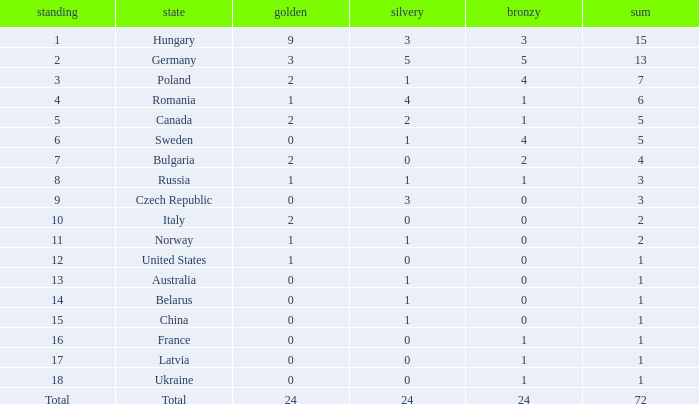Parse the table in full. {'header': ['standing', 'state', 'golden', 'silvery', 'bronzy', 'sum'], 'rows': [['1', 'Hungary', '9', '3', '3', '15'], ['2', 'Germany', '3', '5', '5', '13'], ['3', 'Poland', '2', '1', '4', '7'], ['4', 'Romania', '1', '4', '1', '6'], ['5', 'Canada', '2', '2', '1', '5'], ['6', 'Sweden', '0', '1', '4', '5'], ['7', 'Bulgaria', '2', '0', '2', '4'], ['8', 'Russia', '1', '1', '1', '3'], ['9', 'Czech Republic', '0', '3', '0', '3'], ['10', 'Italy', '2', '0', '0', '2'], ['11', 'Norway', '1', '1', '0', '2'], ['12', 'United States', '1', '0', '0', '1'], ['13', 'Australia', '0', '1', '0', '1'], ['14', 'Belarus', '0', '1', '0', '1'], ['15', 'China', '0', '1', '0', '1'], ['16', 'France', '0', '0', '1', '1'], ['17', 'Latvia', '0', '0', '1', '1'], ['18', 'Ukraine', '0', '0', '1', '1'], ['Total', 'Total', '24', '24', '24', '72']]} What nation has 0 as the silver, 1 as the bronze, with 18 as the rank? Ukraine. 